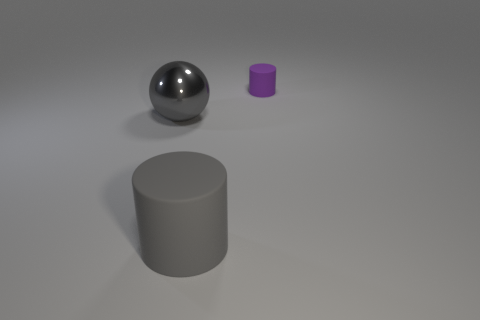Are there any other things that are the same material as the gray sphere?
Ensure brevity in your answer.  No. Is the ball the same color as the big cylinder?
Your answer should be compact. Yes. Do the tiny cylinder and the large gray sphere have the same material?
Ensure brevity in your answer.  No. Are there any other gray cylinders that have the same material as the tiny cylinder?
Your answer should be very brief. Yes. There is a large thing that is to the left of the rubber cylinder that is in front of the rubber cylinder that is to the right of the gray matte cylinder; what is its color?
Make the answer very short. Gray. How many gray objects are metallic cylinders or spheres?
Your response must be concise. 1. How many small purple things have the same shape as the gray metallic thing?
Keep it short and to the point. 0. There is a object that is the same size as the ball; what is its shape?
Provide a succinct answer. Cylinder. There is a big shiny sphere; are there any tiny purple rubber things in front of it?
Give a very brief answer. No. There is a matte thing that is in front of the small cylinder; are there any purple objects in front of it?
Give a very brief answer. No. 